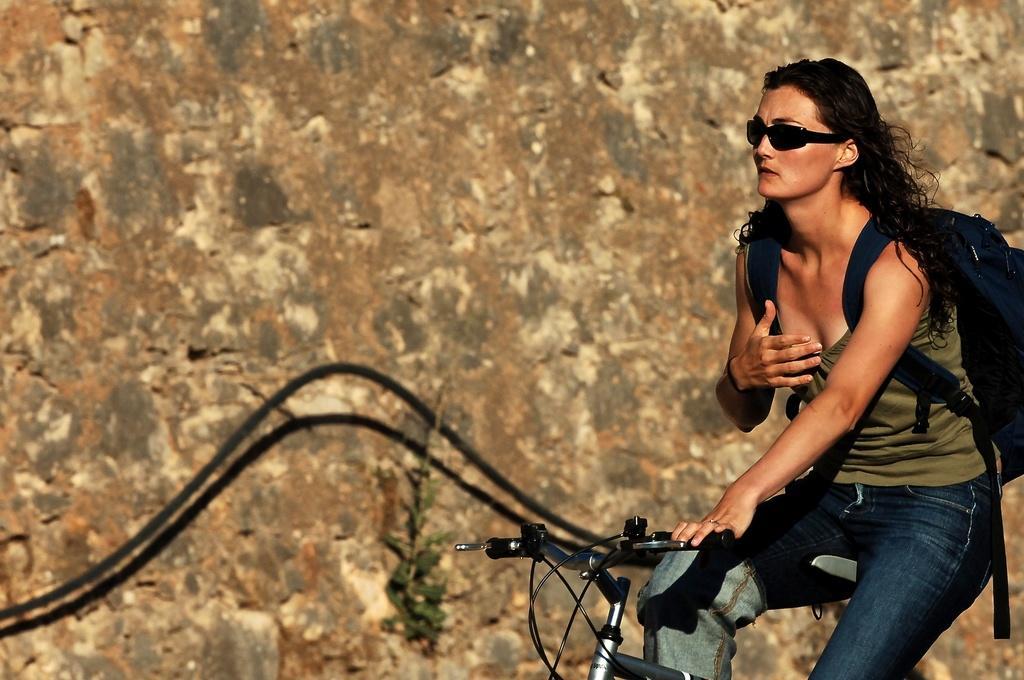Can you describe this image briefly? In this picture there is a girl who is wearing sun glasses at the right side of the image, she is riding a bicycle, it seems to be day time and there is a wall at the left side of the image. 